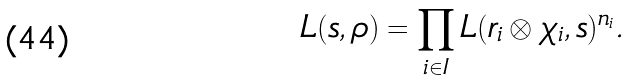<formula> <loc_0><loc_0><loc_500><loc_500>L ( s , \rho ) = \prod _ { i \in I } L ( r _ { i } \otimes \chi _ { i } , s ) ^ { n _ { i } } .</formula> 